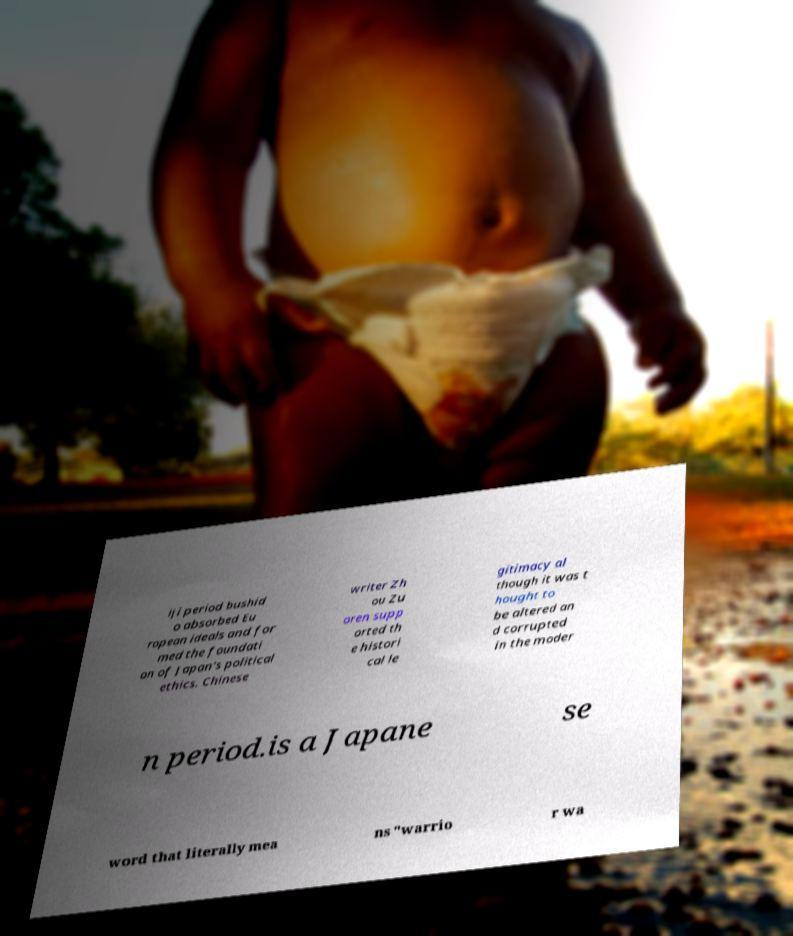Can you accurately transcribe the text from the provided image for me? iji period bushid o absorbed Eu ropean ideals and for med the foundati on of Japan's political ethics. Chinese writer Zh ou Zu oren supp orted th e histori cal le gitimacy al though it was t hought to be altered an d corrupted in the moder n period.is a Japane se word that literally mea ns "warrio r wa 